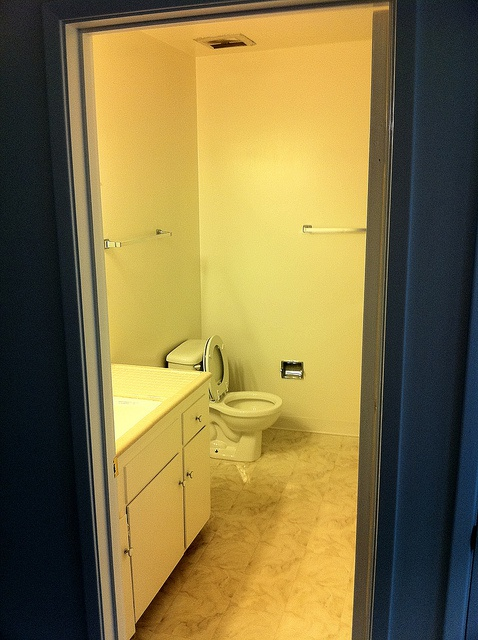Describe the objects in this image and their specific colors. I can see toilet in black, tan, khaki, and olive tones and sink in black, khaki, lightyellow, and tan tones in this image. 